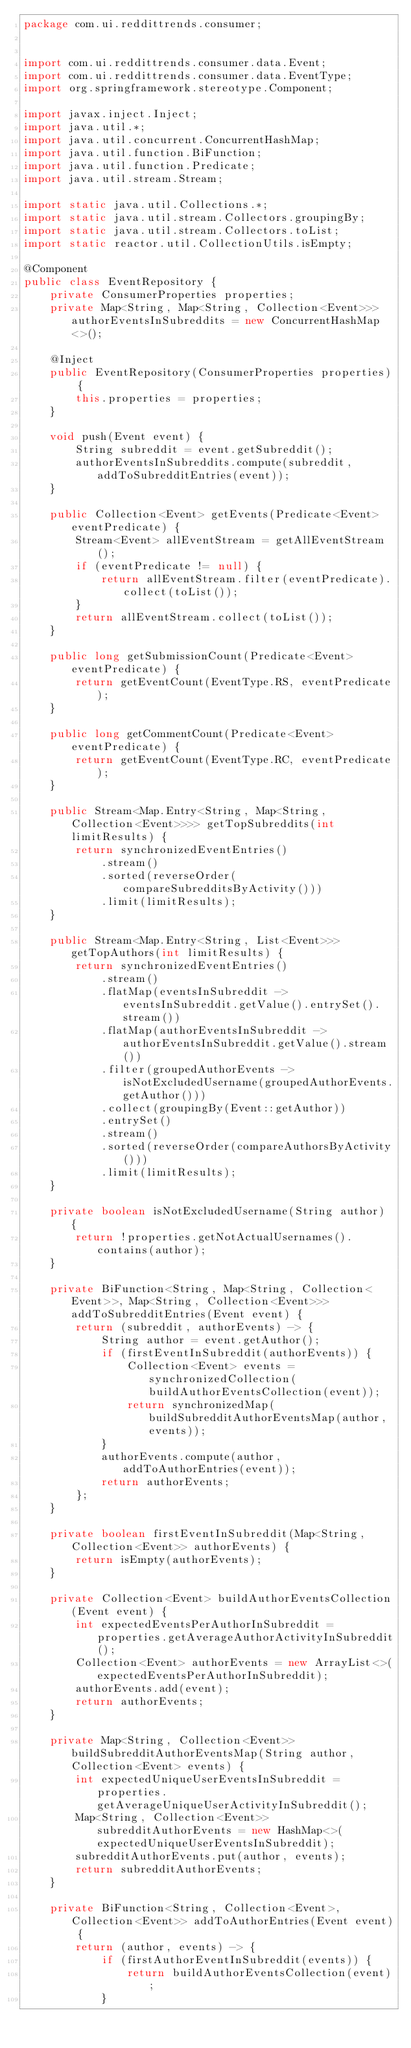<code> <loc_0><loc_0><loc_500><loc_500><_Java_>package com.ui.reddittrends.consumer;


import com.ui.reddittrends.consumer.data.Event;
import com.ui.reddittrends.consumer.data.EventType;
import org.springframework.stereotype.Component;

import javax.inject.Inject;
import java.util.*;
import java.util.concurrent.ConcurrentHashMap;
import java.util.function.BiFunction;
import java.util.function.Predicate;
import java.util.stream.Stream;

import static java.util.Collections.*;
import static java.util.stream.Collectors.groupingBy;
import static java.util.stream.Collectors.toList;
import static reactor.util.CollectionUtils.isEmpty;

@Component
public class EventRepository {
    private ConsumerProperties properties;
    private Map<String, Map<String, Collection<Event>>> authorEventsInSubreddits = new ConcurrentHashMap<>();

    @Inject
    public EventRepository(ConsumerProperties properties) {
        this.properties = properties;
    }

    void push(Event event) {
        String subreddit = event.getSubreddit();
        authorEventsInSubreddits.compute(subreddit, addToSubredditEntries(event));
    }

    public Collection<Event> getEvents(Predicate<Event> eventPredicate) {
        Stream<Event> allEventStream = getAllEventStream();
        if (eventPredicate != null) {
            return allEventStream.filter(eventPredicate).collect(toList());
        }
        return allEventStream.collect(toList());
    }

    public long getSubmissionCount(Predicate<Event> eventPredicate) {
        return getEventCount(EventType.RS, eventPredicate);
    }

    public long getCommentCount(Predicate<Event> eventPredicate) {
        return getEventCount(EventType.RC, eventPredicate);
    }

    public Stream<Map.Entry<String, Map<String, Collection<Event>>>> getTopSubreddits(int limitResults) {
        return synchronizedEventEntries()
            .stream()
            .sorted(reverseOrder(compareSubredditsByActivity()))
            .limit(limitResults);
    }

    public Stream<Map.Entry<String, List<Event>>> getTopAuthors(int limitResults) {
        return synchronizedEventEntries()
            .stream()
            .flatMap(eventsInSubreddit -> eventsInSubreddit.getValue().entrySet().stream())
            .flatMap(authorEventsInSubreddit -> authorEventsInSubreddit.getValue().stream())
            .filter(groupedAuthorEvents -> isNotExcludedUsername(groupedAuthorEvents.getAuthor()))
            .collect(groupingBy(Event::getAuthor))
            .entrySet()
            .stream()
            .sorted(reverseOrder(compareAuthorsByActivity()))
            .limit(limitResults);
    }

    private boolean isNotExcludedUsername(String author) {
        return !properties.getNotActualUsernames().contains(author);
    }

    private BiFunction<String, Map<String, Collection<Event>>, Map<String, Collection<Event>>> addToSubredditEntries(Event event) {
        return (subreddit, authorEvents) -> {
            String author = event.getAuthor();
            if (firstEventInSubreddit(authorEvents)) {
                Collection<Event> events = synchronizedCollection(buildAuthorEventsCollection(event));
                return synchronizedMap(buildSubredditAuthorEventsMap(author, events));
            }
            authorEvents.compute(author, addToAuthorEntries(event));
            return authorEvents;
        };
    }

    private boolean firstEventInSubreddit(Map<String, Collection<Event>> authorEvents) {
        return isEmpty(authorEvents);
    }

    private Collection<Event> buildAuthorEventsCollection(Event event) {
        int expectedEventsPerAuthorInSubreddit = properties.getAverageAuthorActivityInSubreddit();
        Collection<Event> authorEvents = new ArrayList<>(expectedEventsPerAuthorInSubreddit);
        authorEvents.add(event);
        return authorEvents;
    }

    private Map<String, Collection<Event>> buildSubredditAuthorEventsMap(String author, Collection<Event> events) {
        int expectedUniqueUserEventsInSubreddit = properties.getAverageUniqueUserActivityInSubreddit();
        Map<String, Collection<Event>> subredditAuthorEvents = new HashMap<>(expectedUniqueUserEventsInSubreddit);
        subredditAuthorEvents.put(author, events);
        return subredditAuthorEvents;
    }

    private BiFunction<String, Collection<Event>, Collection<Event>> addToAuthorEntries(Event event) {
        return (author, events) -> {
            if (firstAuthorEventInSubreddit(events)) {
                return buildAuthorEventsCollection(event);
            }</code> 